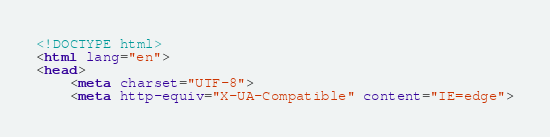<code> <loc_0><loc_0><loc_500><loc_500><_HTML_><!DOCTYPE html>
<html lang="en">
<head>
    <meta charset="UTF-8">
    <meta http-equiv="X-UA-Compatible" content="IE=edge"></code> 